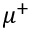Convert formula to latex. <formula><loc_0><loc_0><loc_500><loc_500>\mu ^ { + }</formula> 